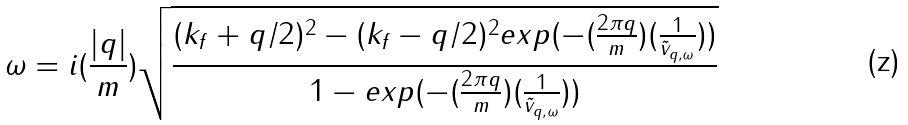Convert formula to latex. <formula><loc_0><loc_0><loc_500><loc_500>\omega = i ( \frac { | q | } { m } ) \sqrt { \frac { ( k _ { f } + q / 2 ) ^ { 2 } - ( k _ { f } - q / 2 ) ^ { 2 } e x p ( - ( \frac { 2 \pi q } { m } ) ( \frac { 1 } { { \tilde { v } } _ { q , \omega } } ) ) } { 1 - e x p ( - ( \frac { 2 \pi q } { m } ) ( \frac { 1 } { { \tilde { v } } _ { q , \omega } } ) ) } }</formula> 